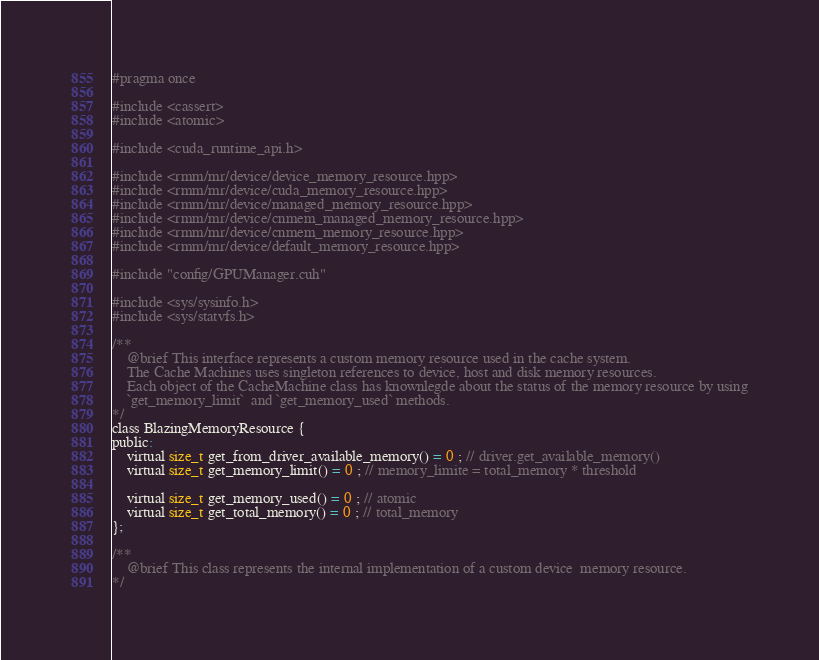Convert code to text. <code><loc_0><loc_0><loc_500><loc_500><_C_>#pragma once 

#include <cassert>
#include <atomic>

#include <cuda_runtime_api.h>

#include <rmm/mr/device/device_memory_resource.hpp>
#include <rmm/mr/device/cuda_memory_resource.hpp>
#include <rmm/mr/device/managed_memory_resource.hpp>
#include <rmm/mr/device/cnmem_managed_memory_resource.hpp>
#include <rmm/mr/device/cnmem_memory_resource.hpp>
#include <rmm/mr/device/default_memory_resource.hpp>

#include "config/GPUManager.cuh"

#include <sys/sysinfo.h>
#include <sys/statvfs.h>

/**
	@brief This interface represents a custom memory resource used in the cache system.
    The Cache Machines uses singleton references to device, host and disk memory resources. 
    Each object of the CacheMachine class has knownlegde about the status of the memory resource by using
    `get_memory_limit`  and `get_memory_used` methods.
*/
class BlazingMemoryResource {
public:
	virtual size_t get_from_driver_available_memory() = 0 ; // driver.get_available_memory()
	virtual size_t get_memory_limit() = 0 ; // memory_limite = total_memory * threshold

	virtual size_t get_memory_used() = 0 ; // atomic 
	virtual size_t get_total_memory() = 0 ; // total_memory
};

/**
	@brief This class represents the internal implementation of a custom device  memory resource.
*/</code> 